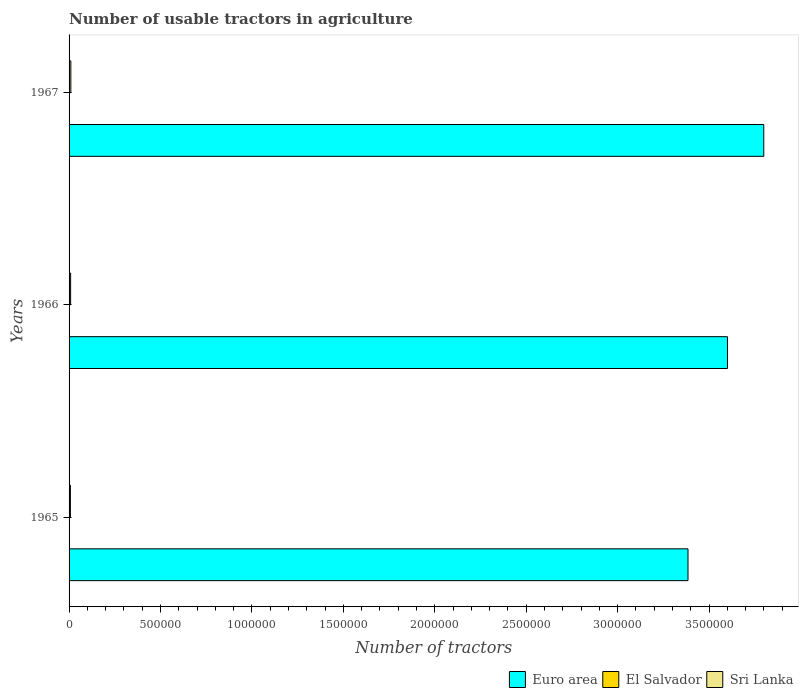How many different coloured bars are there?
Your answer should be very brief. 3. How many groups of bars are there?
Provide a succinct answer. 3. Are the number of bars per tick equal to the number of legend labels?
Provide a short and direct response. Yes. Are the number of bars on each tick of the Y-axis equal?
Offer a terse response. Yes. How many bars are there on the 3rd tick from the top?
Keep it short and to the point. 3. How many bars are there on the 3rd tick from the bottom?
Your answer should be compact. 3. What is the label of the 2nd group of bars from the top?
Your answer should be very brief. 1966. In how many cases, is the number of bars for a given year not equal to the number of legend labels?
Provide a short and direct response. 0. What is the number of usable tractors in agriculture in Sri Lanka in 1965?
Your response must be concise. 7293. Across all years, what is the maximum number of usable tractors in agriculture in Sri Lanka?
Provide a short and direct response. 9700. Across all years, what is the minimum number of usable tractors in agriculture in Euro area?
Provide a succinct answer. 3.39e+06. In which year was the number of usable tractors in agriculture in Sri Lanka maximum?
Ensure brevity in your answer.  1967. In which year was the number of usable tractors in agriculture in Sri Lanka minimum?
Offer a very short reply. 1965. What is the total number of usable tractors in agriculture in Euro area in the graph?
Offer a terse response. 1.08e+07. What is the difference between the number of usable tractors in agriculture in Euro area in 1965 and that in 1967?
Make the answer very short. -4.14e+05. What is the difference between the number of usable tractors in agriculture in Sri Lanka in 1966 and the number of usable tractors in agriculture in El Salvador in 1967?
Keep it short and to the point. 6300. What is the average number of usable tractors in agriculture in Euro area per year?
Your answer should be very brief. 3.60e+06. In the year 1966, what is the difference between the number of usable tractors in agriculture in El Salvador and number of usable tractors in agriculture in Euro area?
Offer a terse response. -3.60e+06. In how many years, is the number of usable tractors in agriculture in El Salvador greater than 1800000 ?
Keep it short and to the point. 0. What is the ratio of the number of usable tractors in agriculture in Sri Lanka in 1965 to that in 1966?
Your response must be concise. 0.86. What is the difference between the highest and the second highest number of usable tractors in agriculture in El Salvador?
Offer a very short reply. 350. What is the difference between the highest and the lowest number of usable tractors in agriculture in Sri Lanka?
Your answer should be compact. 2407. In how many years, is the number of usable tractors in agriculture in El Salvador greater than the average number of usable tractors in agriculture in El Salvador taken over all years?
Make the answer very short. 1. Is the sum of the number of usable tractors in agriculture in Euro area in 1965 and 1966 greater than the maximum number of usable tractors in agriculture in Sri Lanka across all years?
Offer a very short reply. Yes. What does the 1st bar from the bottom in 1967 represents?
Provide a short and direct response. Euro area. Is it the case that in every year, the sum of the number of usable tractors in agriculture in El Salvador and number of usable tractors in agriculture in Euro area is greater than the number of usable tractors in agriculture in Sri Lanka?
Your answer should be very brief. Yes. Are all the bars in the graph horizontal?
Your answer should be compact. Yes. Are the values on the major ticks of X-axis written in scientific E-notation?
Make the answer very short. No. Does the graph contain grids?
Make the answer very short. No. How many legend labels are there?
Your response must be concise. 3. What is the title of the graph?
Provide a succinct answer. Number of usable tractors in agriculture. Does "Japan" appear as one of the legend labels in the graph?
Keep it short and to the point. No. What is the label or title of the X-axis?
Make the answer very short. Number of tractors. What is the label or title of the Y-axis?
Offer a terse response. Years. What is the Number of tractors in Euro area in 1965?
Keep it short and to the point. 3.39e+06. What is the Number of tractors of El Salvador in 1965?
Ensure brevity in your answer.  1800. What is the Number of tractors in Sri Lanka in 1965?
Offer a terse response. 7293. What is the Number of tractors of Euro area in 1966?
Make the answer very short. 3.60e+06. What is the Number of tractors of El Salvador in 1966?
Your response must be concise. 1850. What is the Number of tractors of Sri Lanka in 1966?
Give a very brief answer. 8500. What is the Number of tractors in Euro area in 1967?
Give a very brief answer. 3.80e+06. What is the Number of tractors in El Salvador in 1967?
Your answer should be very brief. 2200. What is the Number of tractors in Sri Lanka in 1967?
Make the answer very short. 9700. Across all years, what is the maximum Number of tractors in Euro area?
Offer a terse response. 3.80e+06. Across all years, what is the maximum Number of tractors in El Salvador?
Your answer should be very brief. 2200. Across all years, what is the maximum Number of tractors in Sri Lanka?
Make the answer very short. 9700. Across all years, what is the minimum Number of tractors of Euro area?
Give a very brief answer. 3.39e+06. Across all years, what is the minimum Number of tractors of El Salvador?
Provide a succinct answer. 1800. Across all years, what is the minimum Number of tractors in Sri Lanka?
Your response must be concise. 7293. What is the total Number of tractors of Euro area in the graph?
Your response must be concise. 1.08e+07. What is the total Number of tractors of El Salvador in the graph?
Your answer should be very brief. 5850. What is the total Number of tractors in Sri Lanka in the graph?
Your response must be concise. 2.55e+04. What is the difference between the Number of tractors of Euro area in 1965 and that in 1966?
Give a very brief answer. -2.16e+05. What is the difference between the Number of tractors of El Salvador in 1965 and that in 1966?
Ensure brevity in your answer.  -50. What is the difference between the Number of tractors of Sri Lanka in 1965 and that in 1966?
Keep it short and to the point. -1207. What is the difference between the Number of tractors of Euro area in 1965 and that in 1967?
Keep it short and to the point. -4.14e+05. What is the difference between the Number of tractors of El Salvador in 1965 and that in 1967?
Your answer should be compact. -400. What is the difference between the Number of tractors of Sri Lanka in 1965 and that in 1967?
Your response must be concise. -2407. What is the difference between the Number of tractors of Euro area in 1966 and that in 1967?
Make the answer very short. -1.99e+05. What is the difference between the Number of tractors of El Salvador in 1966 and that in 1967?
Your response must be concise. -350. What is the difference between the Number of tractors of Sri Lanka in 1966 and that in 1967?
Your response must be concise. -1200. What is the difference between the Number of tractors in Euro area in 1965 and the Number of tractors in El Salvador in 1966?
Give a very brief answer. 3.38e+06. What is the difference between the Number of tractors in Euro area in 1965 and the Number of tractors in Sri Lanka in 1966?
Your response must be concise. 3.38e+06. What is the difference between the Number of tractors in El Salvador in 1965 and the Number of tractors in Sri Lanka in 1966?
Keep it short and to the point. -6700. What is the difference between the Number of tractors in Euro area in 1965 and the Number of tractors in El Salvador in 1967?
Provide a short and direct response. 3.38e+06. What is the difference between the Number of tractors in Euro area in 1965 and the Number of tractors in Sri Lanka in 1967?
Your response must be concise. 3.38e+06. What is the difference between the Number of tractors in El Salvador in 1965 and the Number of tractors in Sri Lanka in 1967?
Keep it short and to the point. -7900. What is the difference between the Number of tractors of Euro area in 1966 and the Number of tractors of El Salvador in 1967?
Give a very brief answer. 3.60e+06. What is the difference between the Number of tractors of Euro area in 1966 and the Number of tractors of Sri Lanka in 1967?
Provide a succinct answer. 3.59e+06. What is the difference between the Number of tractors of El Salvador in 1966 and the Number of tractors of Sri Lanka in 1967?
Offer a terse response. -7850. What is the average Number of tractors in Euro area per year?
Make the answer very short. 3.60e+06. What is the average Number of tractors of El Salvador per year?
Give a very brief answer. 1950. What is the average Number of tractors of Sri Lanka per year?
Your answer should be very brief. 8497.67. In the year 1965, what is the difference between the Number of tractors in Euro area and Number of tractors in El Salvador?
Give a very brief answer. 3.38e+06. In the year 1965, what is the difference between the Number of tractors of Euro area and Number of tractors of Sri Lanka?
Offer a terse response. 3.38e+06. In the year 1965, what is the difference between the Number of tractors of El Salvador and Number of tractors of Sri Lanka?
Offer a very short reply. -5493. In the year 1966, what is the difference between the Number of tractors of Euro area and Number of tractors of El Salvador?
Provide a succinct answer. 3.60e+06. In the year 1966, what is the difference between the Number of tractors in Euro area and Number of tractors in Sri Lanka?
Provide a short and direct response. 3.59e+06. In the year 1966, what is the difference between the Number of tractors in El Salvador and Number of tractors in Sri Lanka?
Provide a short and direct response. -6650. In the year 1967, what is the difference between the Number of tractors in Euro area and Number of tractors in El Salvador?
Offer a very short reply. 3.80e+06. In the year 1967, what is the difference between the Number of tractors of Euro area and Number of tractors of Sri Lanka?
Keep it short and to the point. 3.79e+06. In the year 1967, what is the difference between the Number of tractors of El Salvador and Number of tractors of Sri Lanka?
Offer a very short reply. -7500. What is the ratio of the Number of tractors of Euro area in 1965 to that in 1966?
Your answer should be compact. 0.94. What is the ratio of the Number of tractors of Sri Lanka in 1965 to that in 1966?
Offer a very short reply. 0.86. What is the ratio of the Number of tractors of Euro area in 1965 to that in 1967?
Your answer should be compact. 0.89. What is the ratio of the Number of tractors in El Salvador in 1965 to that in 1967?
Provide a succinct answer. 0.82. What is the ratio of the Number of tractors in Sri Lanka in 1965 to that in 1967?
Keep it short and to the point. 0.75. What is the ratio of the Number of tractors in Euro area in 1966 to that in 1967?
Offer a very short reply. 0.95. What is the ratio of the Number of tractors of El Salvador in 1966 to that in 1967?
Make the answer very short. 0.84. What is the ratio of the Number of tractors in Sri Lanka in 1966 to that in 1967?
Offer a terse response. 0.88. What is the difference between the highest and the second highest Number of tractors of Euro area?
Give a very brief answer. 1.99e+05. What is the difference between the highest and the second highest Number of tractors of El Salvador?
Keep it short and to the point. 350. What is the difference between the highest and the second highest Number of tractors in Sri Lanka?
Give a very brief answer. 1200. What is the difference between the highest and the lowest Number of tractors of Euro area?
Your response must be concise. 4.14e+05. What is the difference between the highest and the lowest Number of tractors in El Salvador?
Your answer should be very brief. 400. What is the difference between the highest and the lowest Number of tractors in Sri Lanka?
Offer a terse response. 2407. 